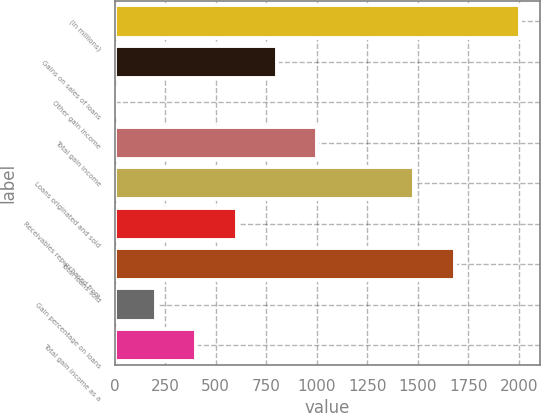Convert chart. <chart><loc_0><loc_0><loc_500><loc_500><bar_chart><fcel>(In millions)<fcel>Gains on sales of loans<fcel>Other gain income<fcel>Total gain income<fcel>Loans originated and sold<fcel>Receivables repurchased from<fcel>Total loans sold<fcel>Gain percentage on loans<fcel>Total gain income as a<nl><fcel>2005<fcel>803.98<fcel>3.3<fcel>1004.15<fcel>1483.8<fcel>603.81<fcel>1683.97<fcel>203.47<fcel>403.64<nl></chart> 